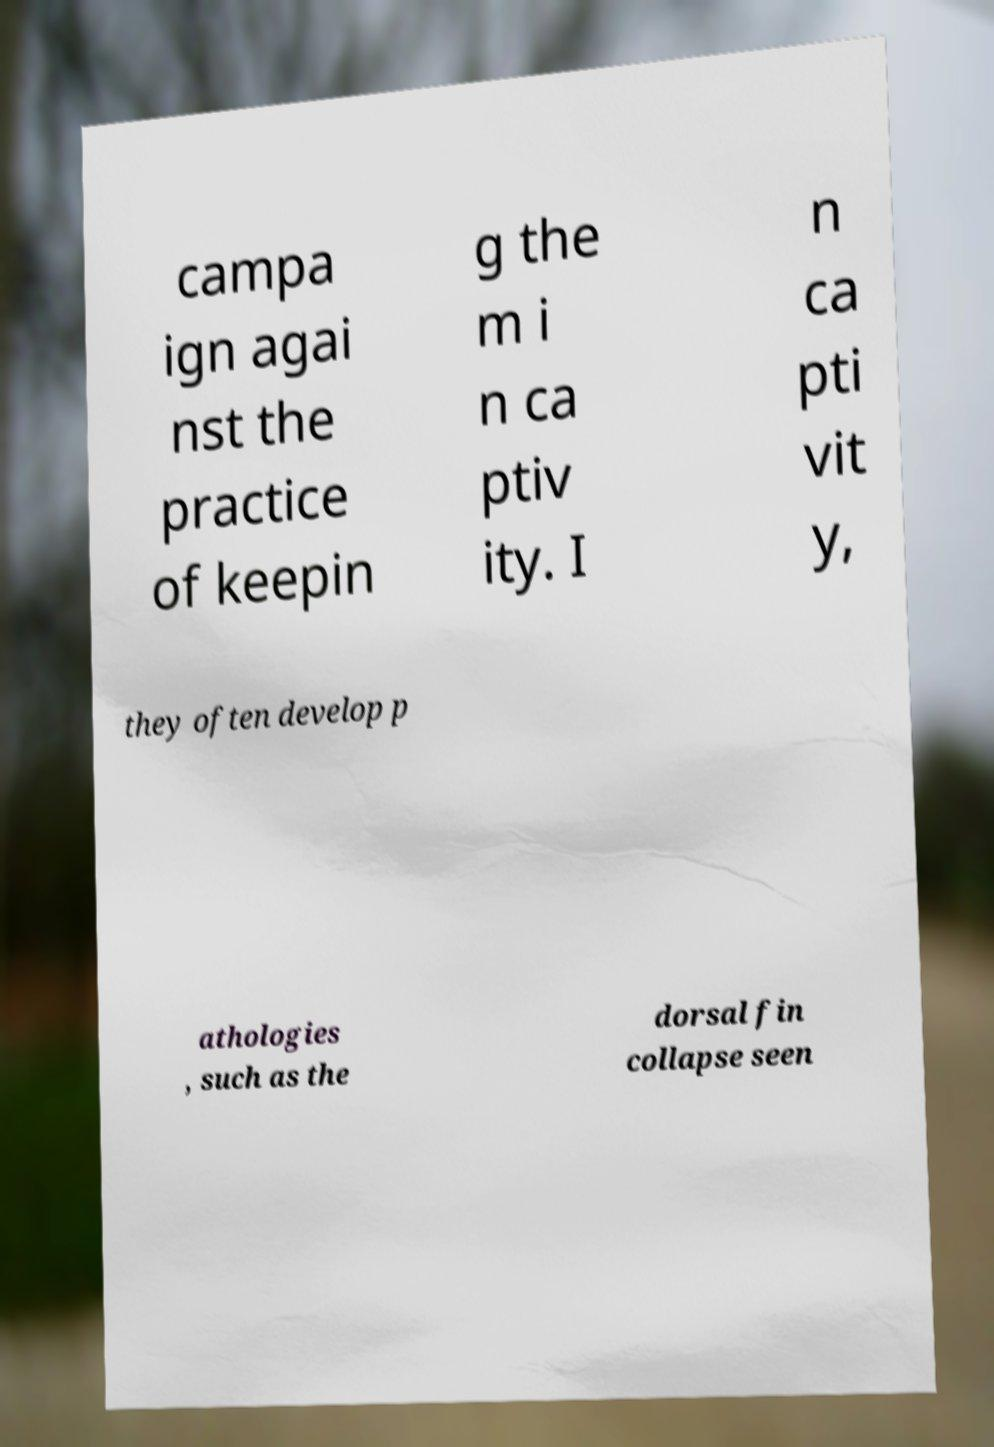Can you accurately transcribe the text from the provided image for me? campa ign agai nst the practice of keepin g the m i n ca ptiv ity. I n ca pti vit y, they often develop p athologies , such as the dorsal fin collapse seen 